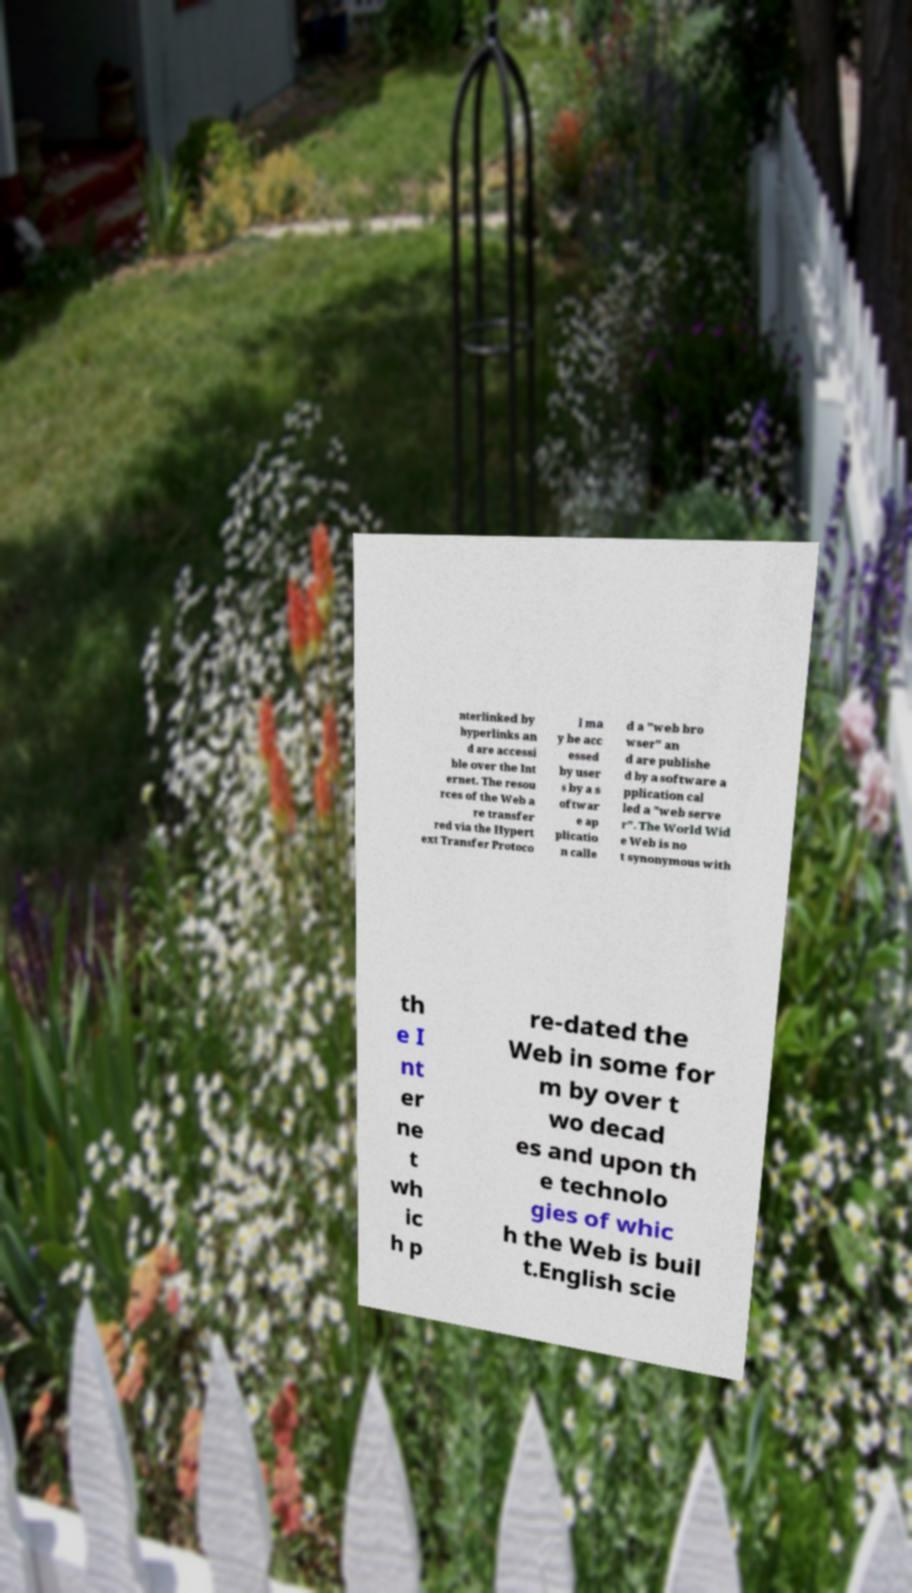Please read and relay the text visible in this image. What does it say? nterlinked by hyperlinks an d are accessi ble over the Int ernet. The resou rces of the Web a re transfer red via the Hypert ext Transfer Protoco l ma y be acc essed by user s by a s oftwar e ap plicatio n calle d a "web bro wser" an d are publishe d by a software a pplication cal led a "web serve r". The World Wid e Web is no t synonymous with th e I nt er ne t wh ic h p re-dated the Web in some for m by over t wo decad es and upon th e technolo gies of whic h the Web is buil t.English scie 